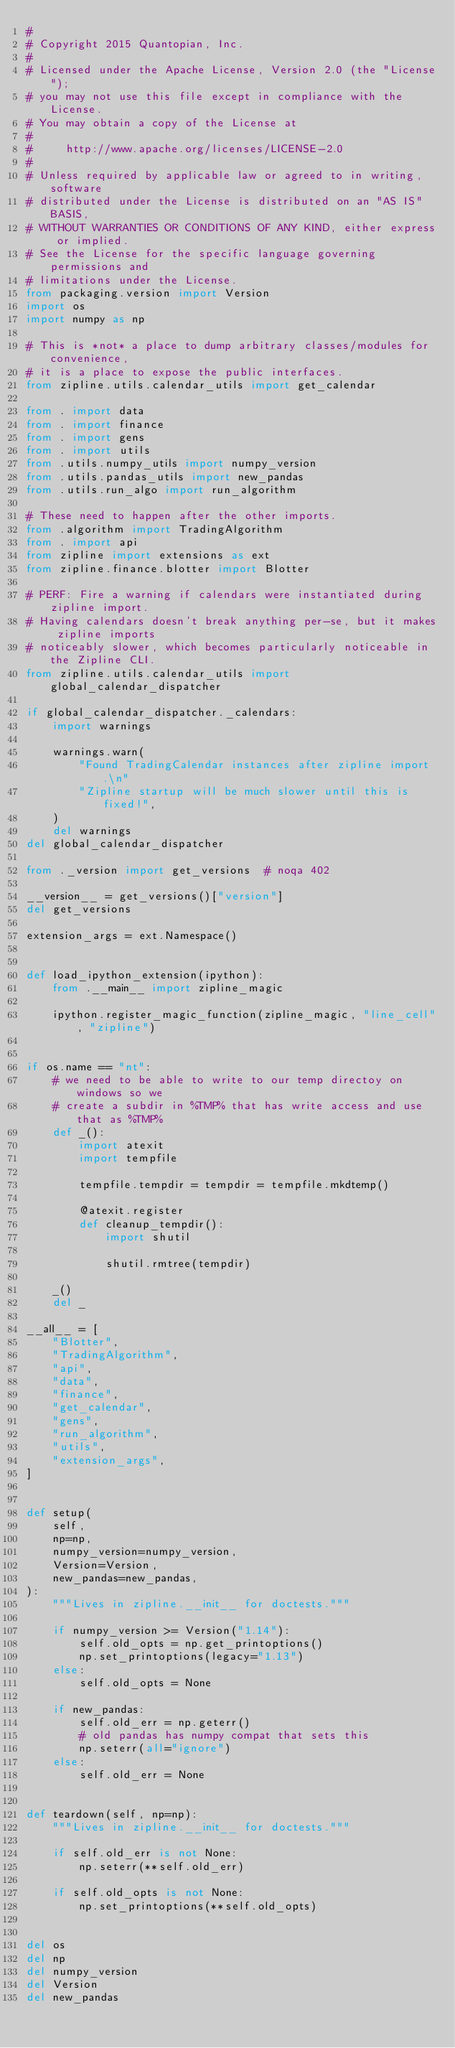Convert code to text. <code><loc_0><loc_0><loc_500><loc_500><_Python_>#
# Copyright 2015 Quantopian, Inc.
#
# Licensed under the Apache License, Version 2.0 (the "License");
# you may not use this file except in compliance with the License.
# You may obtain a copy of the License at
#
#     http://www.apache.org/licenses/LICENSE-2.0
#
# Unless required by applicable law or agreed to in writing, software
# distributed under the License is distributed on an "AS IS" BASIS,
# WITHOUT WARRANTIES OR CONDITIONS OF ANY KIND, either express or implied.
# See the License for the specific language governing permissions and
# limitations under the License.
from packaging.version import Version
import os
import numpy as np

# This is *not* a place to dump arbitrary classes/modules for convenience,
# it is a place to expose the public interfaces.
from zipline.utils.calendar_utils import get_calendar

from . import data
from . import finance
from . import gens
from . import utils
from .utils.numpy_utils import numpy_version
from .utils.pandas_utils import new_pandas
from .utils.run_algo import run_algorithm

# These need to happen after the other imports.
from .algorithm import TradingAlgorithm
from . import api
from zipline import extensions as ext
from zipline.finance.blotter import Blotter

# PERF: Fire a warning if calendars were instantiated during zipline import.
# Having calendars doesn't break anything per-se, but it makes zipline imports
# noticeably slower, which becomes particularly noticeable in the Zipline CLI.
from zipline.utils.calendar_utils import global_calendar_dispatcher

if global_calendar_dispatcher._calendars:
    import warnings

    warnings.warn(
        "Found TradingCalendar instances after zipline import.\n"
        "Zipline startup will be much slower until this is fixed!",
    )
    del warnings
del global_calendar_dispatcher

from ._version import get_versions  # noqa 402

__version__ = get_versions()["version"]
del get_versions

extension_args = ext.Namespace()


def load_ipython_extension(ipython):
    from .__main__ import zipline_magic

    ipython.register_magic_function(zipline_magic, "line_cell", "zipline")


if os.name == "nt":
    # we need to be able to write to our temp directoy on windows so we
    # create a subdir in %TMP% that has write access and use that as %TMP%
    def _():
        import atexit
        import tempfile

        tempfile.tempdir = tempdir = tempfile.mkdtemp()

        @atexit.register
        def cleanup_tempdir():
            import shutil

            shutil.rmtree(tempdir)

    _()
    del _

__all__ = [
    "Blotter",
    "TradingAlgorithm",
    "api",
    "data",
    "finance",
    "get_calendar",
    "gens",
    "run_algorithm",
    "utils",
    "extension_args",
]


def setup(
    self,
    np=np,
    numpy_version=numpy_version,
    Version=Version,
    new_pandas=new_pandas,
):
    """Lives in zipline.__init__ for doctests."""

    if numpy_version >= Version("1.14"):
        self.old_opts = np.get_printoptions()
        np.set_printoptions(legacy="1.13")
    else:
        self.old_opts = None

    if new_pandas:
        self.old_err = np.geterr()
        # old pandas has numpy compat that sets this
        np.seterr(all="ignore")
    else:
        self.old_err = None


def teardown(self, np=np):
    """Lives in zipline.__init__ for doctests."""

    if self.old_err is not None:
        np.seterr(**self.old_err)

    if self.old_opts is not None:
        np.set_printoptions(**self.old_opts)


del os
del np
del numpy_version
del Version
del new_pandas
</code> 